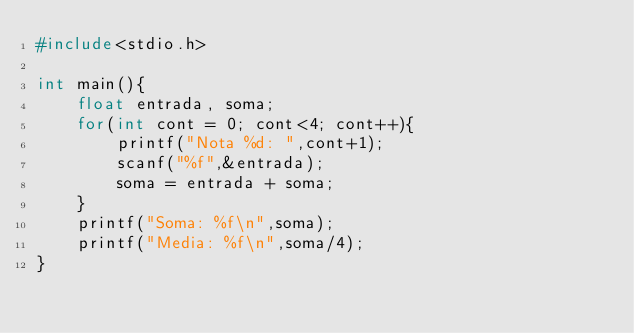<code> <loc_0><loc_0><loc_500><loc_500><_C_>#include<stdio.h>

int main(){
    float entrada, soma;
    for(int cont = 0; cont<4; cont++){
        printf("Nota %d: ",cont+1);
        scanf("%f",&entrada);
        soma = entrada + soma;
    }
    printf("Soma: %f\n",soma);
    printf("Media: %f\n",soma/4);
}</code> 